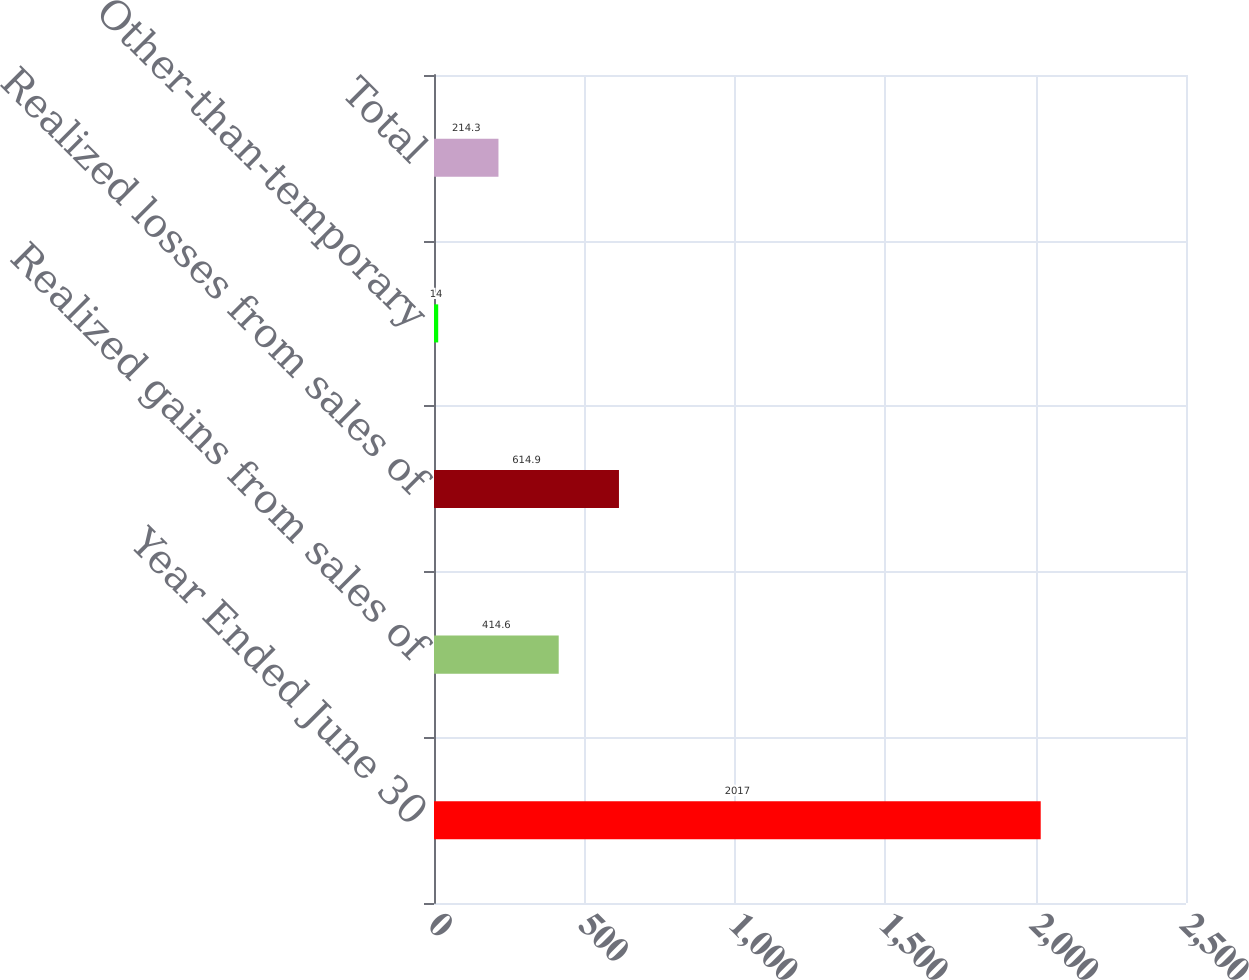<chart> <loc_0><loc_0><loc_500><loc_500><bar_chart><fcel>Year Ended June 30<fcel>Realized gains from sales of<fcel>Realized losses from sales of<fcel>Other-than-temporary<fcel>Total<nl><fcel>2017<fcel>414.6<fcel>614.9<fcel>14<fcel>214.3<nl></chart> 